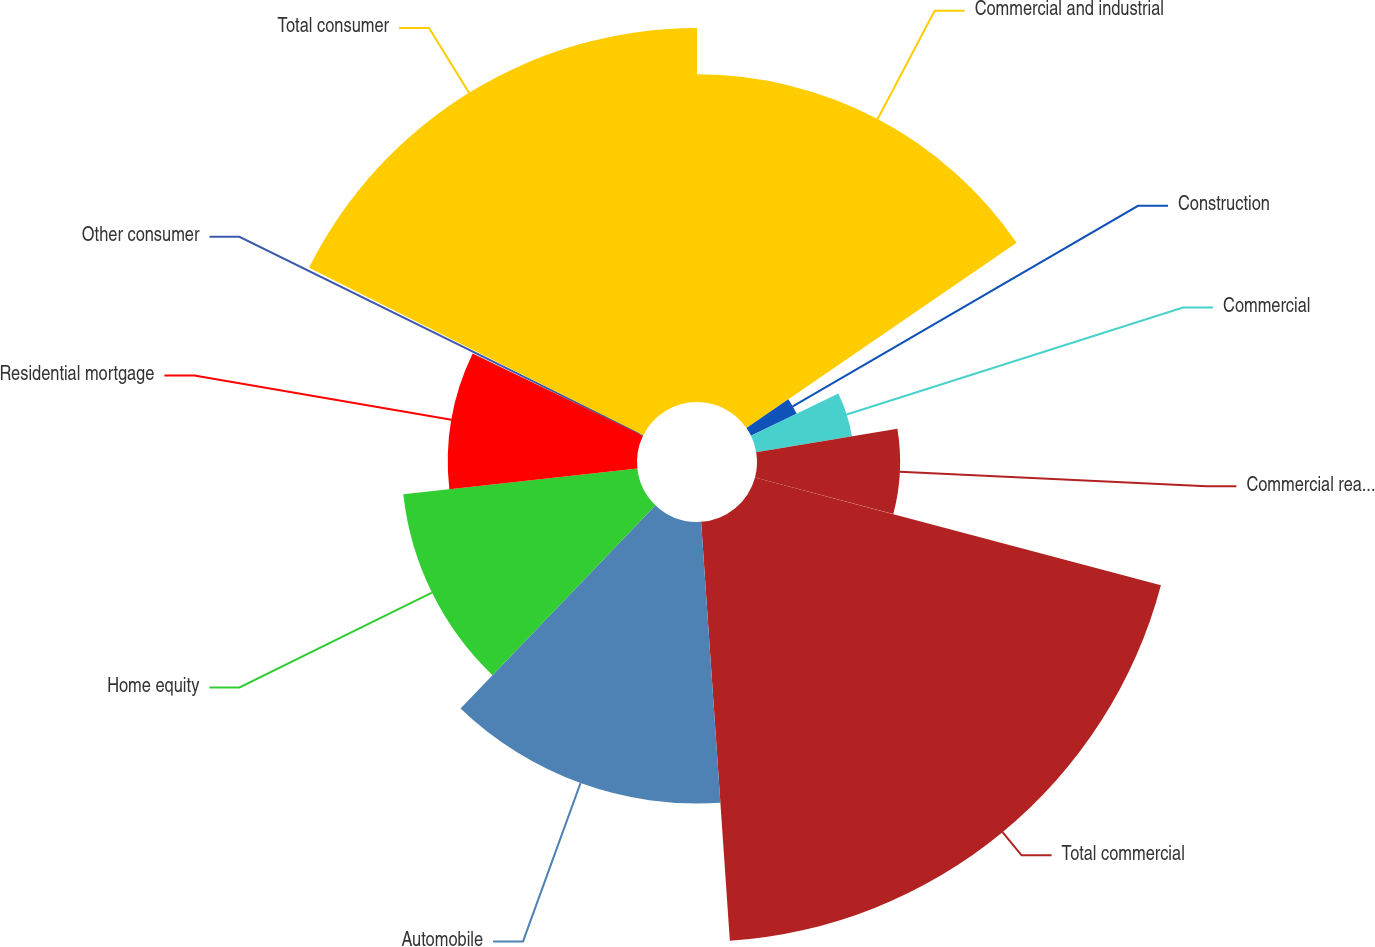Convert chart. <chart><loc_0><loc_0><loc_500><loc_500><pie_chart><fcel>Commercial and industrial<fcel>Construction<fcel>Commercial<fcel>Commercial real estate<fcel>Total commercial<fcel>Automobile<fcel>Home equity<fcel>Residential mortgage<fcel>Other consumer<fcel>Total consumer<nl><fcel>15.43%<fcel>2.39%<fcel>4.57%<fcel>6.74%<fcel>19.78%<fcel>13.26%<fcel>11.09%<fcel>8.91%<fcel>0.22%<fcel>17.61%<nl></chart> 